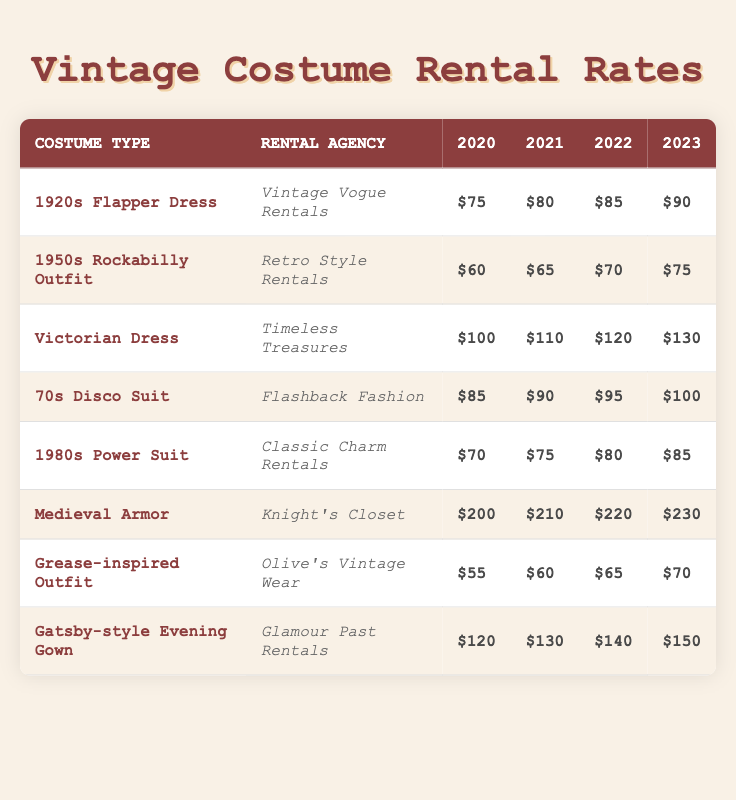What's the rental rate for the 1950s Rockabilly Outfit in 2022? According to the table, the rental rate for the 1950s Rockabilly Outfit listed under Retro Style Rentals in 2022 is $70.
Answer: $70 Which costume type has the highest rental rate in 2023? In 2023, the Medieval Armor from Knight's Closet has the highest rental rate at $230, compared to other costumes listed in the table.
Answer: $230 What is the total rental cost for Medieval Armor from 2020 to 2023? To find the total rental cost, add the individual rates: 200 (2020) + 210 (2021) + 220 (2022) + 230 (2023) = 200 + 210 + 220 + 230 = 860.
Answer: $860 Did the rental rate for the 1920s Flapper Dress increase every year from 2020 to 2023? By reviewing the table, the rental rate for the 1920s Flapper Dress increased from $75 in 2020 to $90 in 2023, confirming it increased every year.
Answer: Yes What was the average rental rate of the Gatsby-style Evening Gown from 2020 to 2023? To calculate the average, first find the total: 120 (2020) + 130 (2021) + 140 (2022) + 150 (2023) = 540. Then divide by 4 (the number of years): 540 / 4 = 135.
Answer: $135 How much more does the Victorian Dress cost to rent in 2023 compared to 2020? The rent in 2023 is $130 and in 2020 it was $100. The difference is calculated as 130 - 100 = 30.
Answer: $30 Is the 1980s Power Suit cheaper to rent than the 1950s Rockabilly Outfit in 2021? In 2021, the rental for the 1980s Power Suit is $75 and for the 1950s Rockabilly Outfit it is $65. Since $75 is greater than $65, the 1980s Power Suit is not cheaper.
Answer: No Is the rental cost for the Grease-inspired Outfit the same in 2021 and 2022? The rental rate for the Grease-inspired Outfit in 2021 is $60 and in 2022 is $65. Since these values are different, the rental costs are not the same.
Answer: No What is the difference in rental rates for the 70s Disco Suit between 2020 and 2023? The rental rate for the 70s Disco Suit is $85 in 2020 and $100 in 2023. The difference is calculated as 100 - 85 = 15.
Answer: $15 